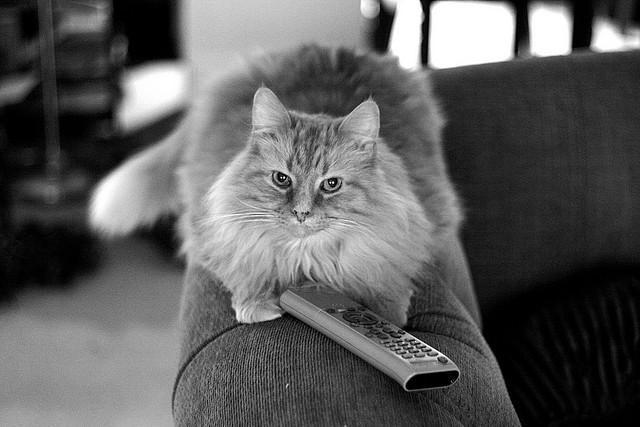How many couches can be seen?
Give a very brief answer. 1. How many motorcycles are there in the image?
Give a very brief answer. 0. 